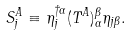Convert formula to latex. <formula><loc_0><loc_0><loc_500><loc_500>S ^ { A } _ { j } \equiv \eta ^ { \dagger \alpha } _ { j } ( T ^ { A } ) _ { \alpha } ^ { \beta } \eta _ { j \beta } .</formula> 